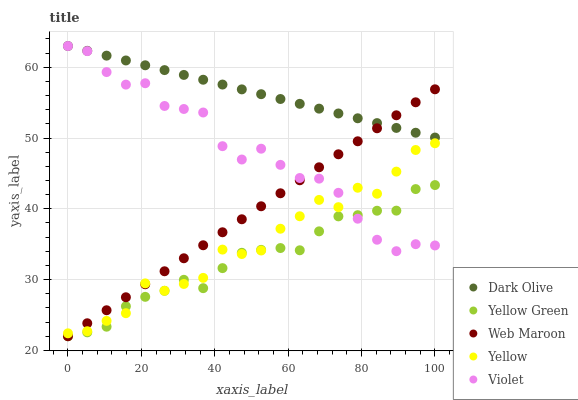Does Yellow Green have the minimum area under the curve?
Answer yes or no. Yes. Does Dark Olive have the maximum area under the curve?
Answer yes or no. Yes. Does Web Maroon have the minimum area under the curve?
Answer yes or no. No. Does Web Maroon have the maximum area under the curve?
Answer yes or no. No. Is Web Maroon the smoothest?
Answer yes or no. Yes. Is Yellow the roughest?
Answer yes or no. Yes. Is Yellow Green the smoothest?
Answer yes or no. No. Is Yellow Green the roughest?
Answer yes or no. No. Does Web Maroon have the lowest value?
Answer yes or no. Yes. Does Yellow have the lowest value?
Answer yes or no. No. Does Violet have the highest value?
Answer yes or no. Yes. Does Web Maroon have the highest value?
Answer yes or no. No. Is Yellow less than Dark Olive?
Answer yes or no. Yes. Is Dark Olive greater than Yellow?
Answer yes or no. Yes. Does Yellow intersect Yellow Green?
Answer yes or no. Yes. Is Yellow less than Yellow Green?
Answer yes or no. No. Is Yellow greater than Yellow Green?
Answer yes or no. No. Does Yellow intersect Dark Olive?
Answer yes or no. No. 